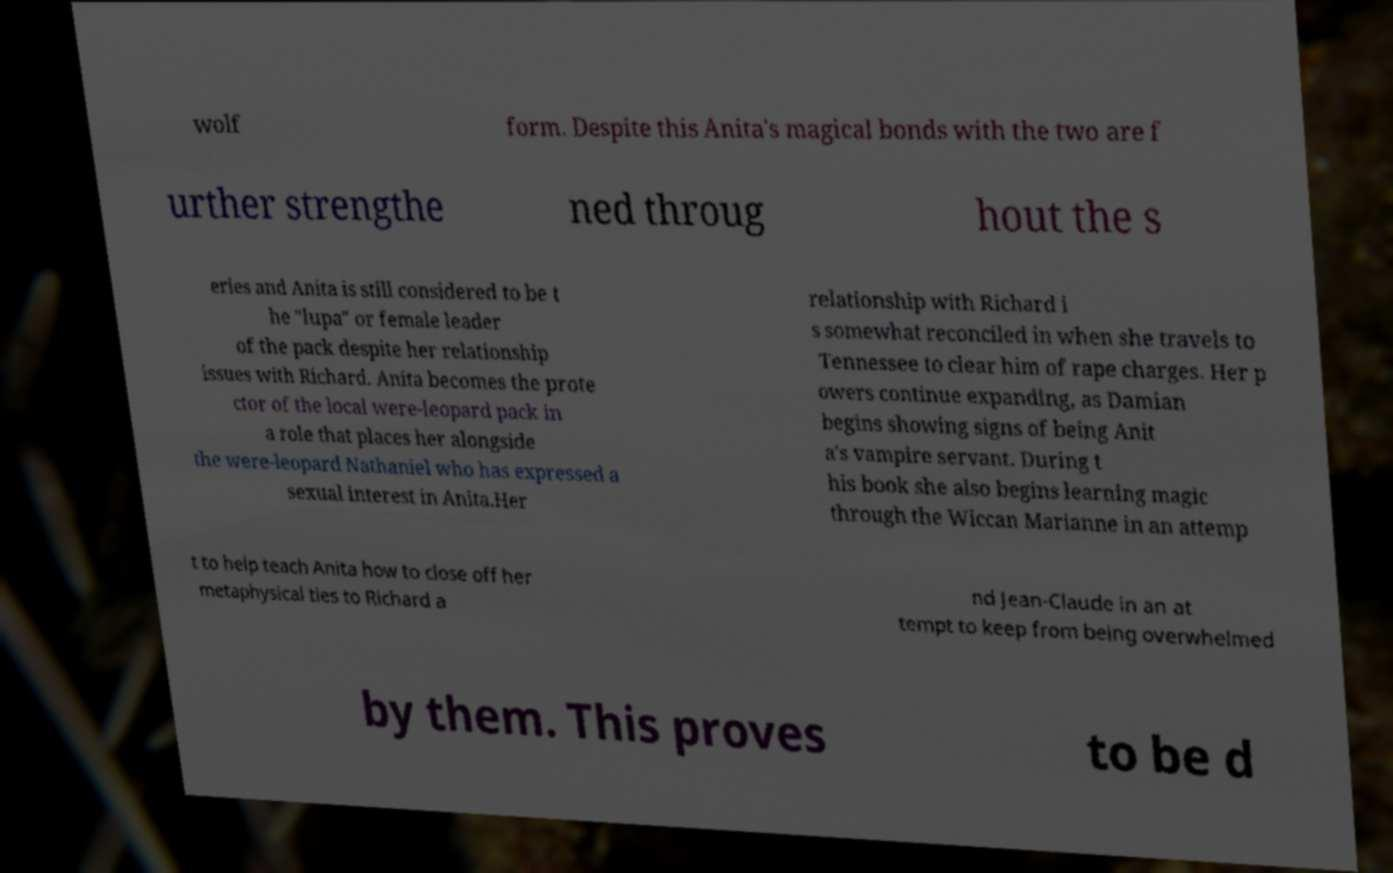I need the written content from this picture converted into text. Can you do that? wolf form. Despite this Anita's magical bonds with the two are f urther strengthe ned throug hout the s eries and Anita is still considered to be t he "lupa" or female leader of the pack despite her relationship issues with Richard. Anita becomes the prote ctor of the local were-leopard pack in a role that places her alongside the were-leopard Nathaniel who has expressed a sexual interest in Anita.Her relationship with Richard i s somewhat reconciled in when she travels to Tennessee to clear him of rape charges. Her p owers continue expanding, as Damian begins showing signs of being Anit a's vampire servant. During t his book she also begins learning magic through the Wiccan Marianne in an attemp t to help teach Anita how to close off her metaphysical ties to Richard a nd Jean-Claude in an at tempt to keep from being overwhelmed by them. This proves to be d 